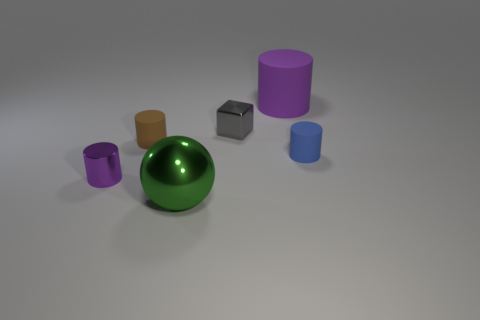Are there any objects that could be a part of a child's toy set? Yes, all of these objects could be part of a child's toy set. Their simple geometric shapes are reminiscent of building blocks or components in a sorting game designed to teach shapes and colors. 